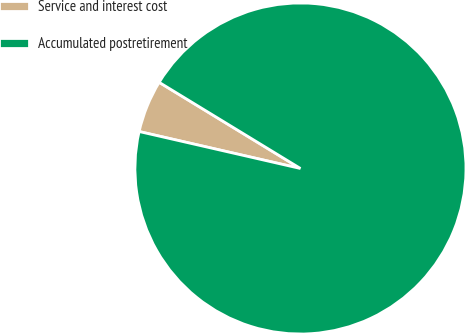<chart> <loc_0><loc_0><loc_500><loc_500><pie_chart><fcel>Service and interest cost<fcel>Accumulated postretirement<nl><fcel>5.13%<fcel>94.87%<nl></chart> 